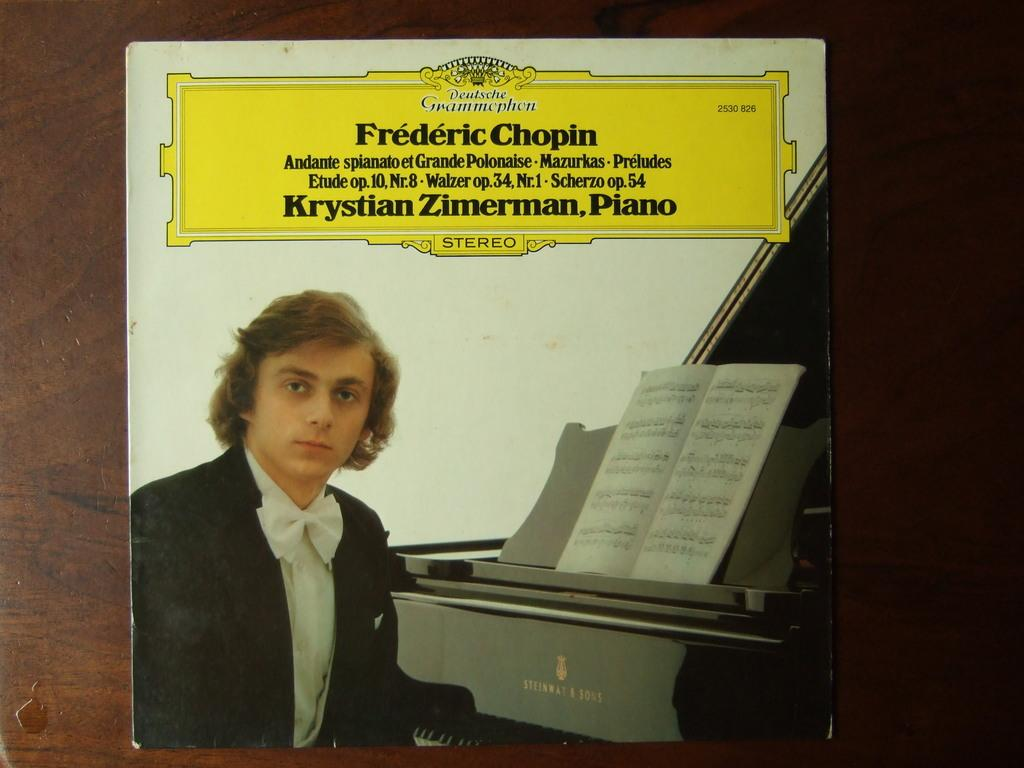<image>
Relay a brief, clear account of the picture shown. Frederic Chopin Krstian Zimerman Piano record with a guy in front of a piano 